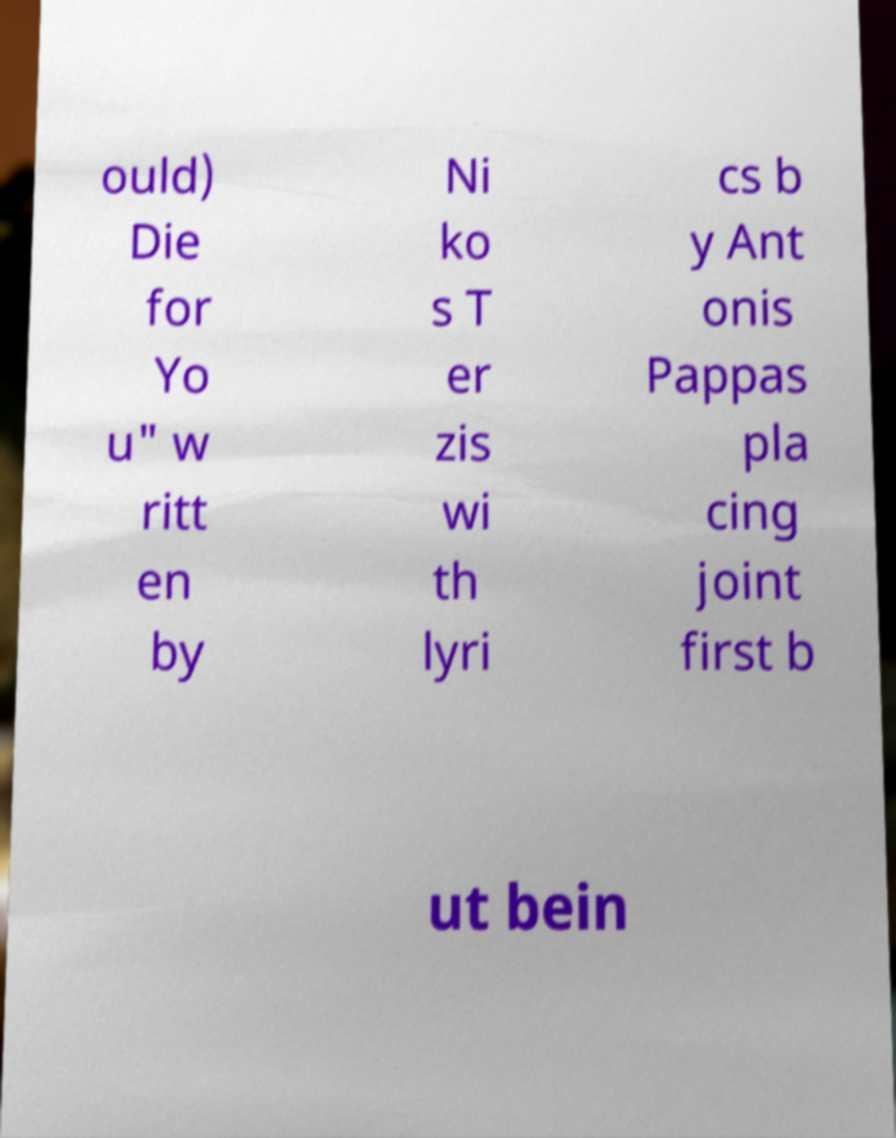Can you read and provide the text displayed in the image?This photo seems to have some interesting text. Can you extract and type it out for me? ould) Die for Yo u" w ritt en by Ni ko s T er zis wi th lyri cs b y Ant onis Pappas pla cing joint first b ut bein 